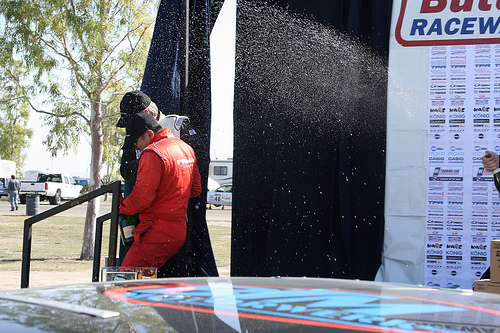<image>
Is the man behind the curtain? No. The man is not behind the curtain. From this viewpoint, the man appears to be positioned elsewhere in the scene. 